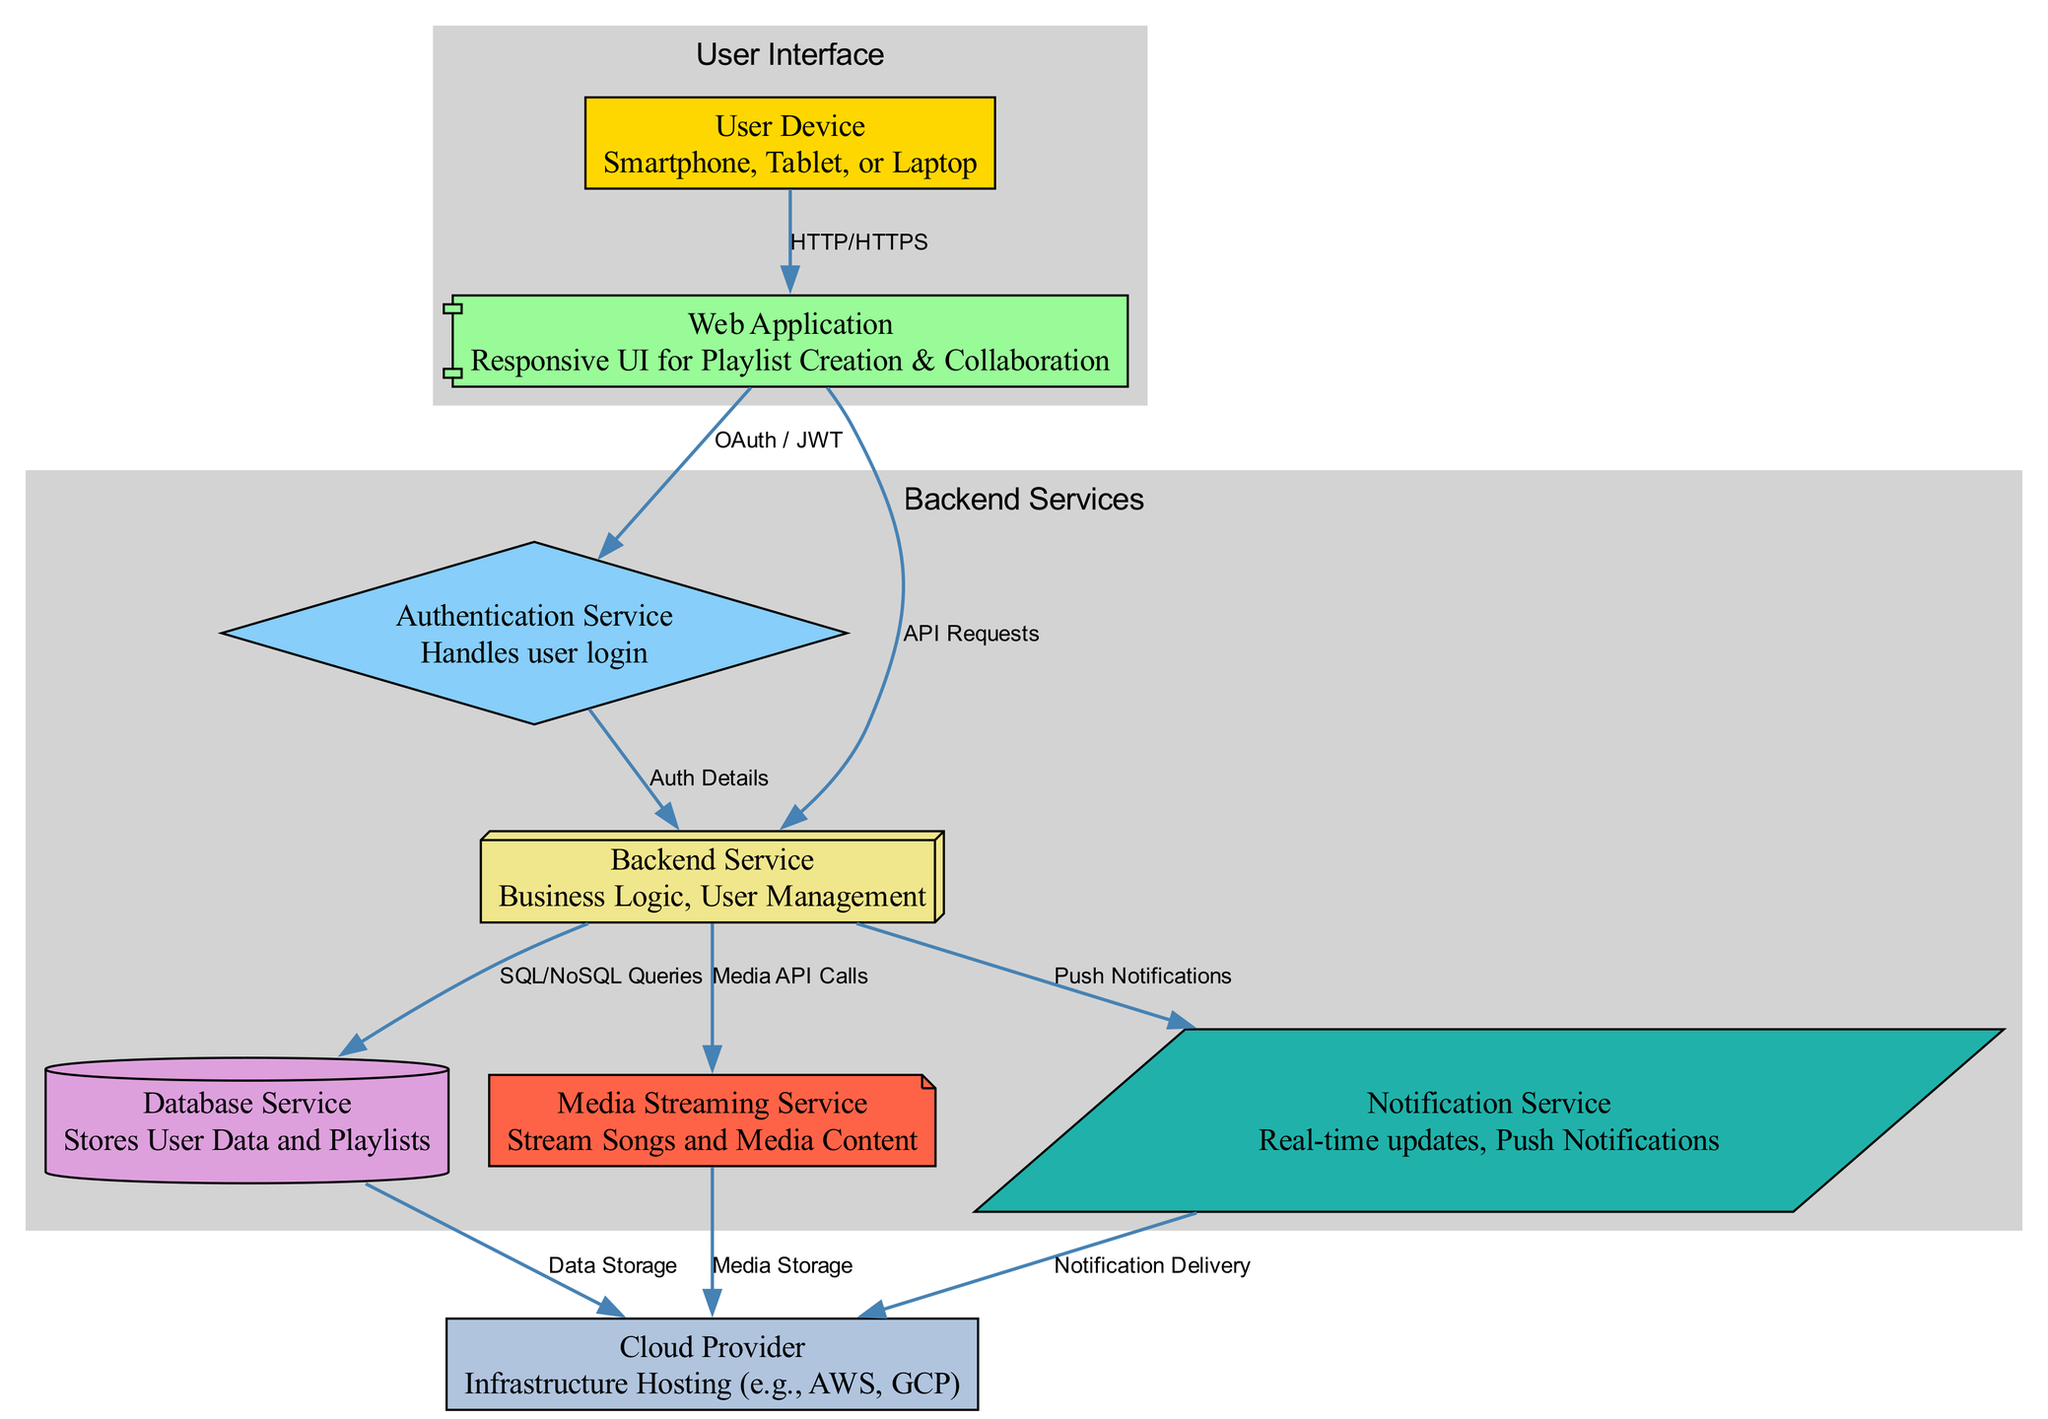What are the two types of user devices mentioned? The diagram identifies three user device types, but two specifically mentioned are smartphone and tablet. These are part of the "User Device" node, which indicates the types of devices users can utilize.
Answer: Smartphone, Tablet How many services are shown in the backend? The diagram shows five backend services, which include authentication service, backend service, database service, media service, and notification service. They are grouped in the "Backend Services" cluster in the diagram.
Answer: Five What type of connection is used between the web application and the authentication service? The connection between the web application and the authentication service is established through OAuth / JWT, specified on the edge connecting those nodes in the diagram.
Answer: OAuth / JWT Which service is responsible for user data storage? The database service is explicitly labeled as the one that stores user data and playlists, as indicated in the node description.
Answer: Database Service How many nodes are classified under the User Interface category? There are two nodes in the User Interface category: user device and web application. This can be deduced by counting the nodes within the "User Interface" subgraph in the diagram.
Answer: Two What does the media service interact with? The media service interacts with both the backend service and the cloud provider, allowing streams of songs and media content. This is evident from the edges connecting these nodes in the diagram.
Answer: Backend Service, Cloud Provider What is the role of the notification service? The notification service is responsible for real-time updates and push notifications, as described in its node's description in the diagram.
Answer: Real-time updates, Push Notifications Which node handles user login? The authentication service is specifically responsible for user login, as mentioned in its description in the diagram.
Answer: Authentication Service What type of connection does the backend service use to communicate with the database service? The backend service uses SQL/NoSQL queries to communicate with the database service. This relationship is directly labeled on the edge that connects these two nodes.
Answer: SQL/NoSQL Queries 